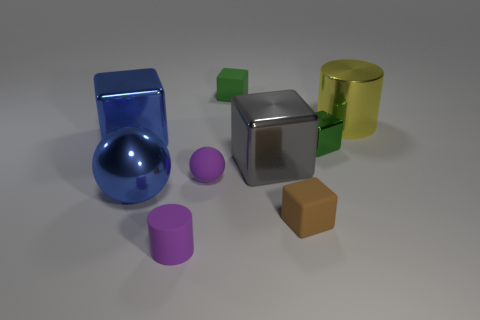How big is the block that is both to the right of the blue metallic sphere and to the left of the gray metallic thing?
Make the answer very short. Small. What material is the gray object that is the same shape as the small brown matte thing?
Give a very brief answer. Metal. How many purple matte balls are there?
Provide a succinct answer. 1. There is a purple rubber thing that is in front of the big metal ball; is its shape the same as the large yellow thing?
Keep it short and to the point. Yes. There is a green object that is the same size as the green matte block; what is its material?
Your response must be concise. Metal. Is there a purple sphere made of the same material as the brown thing?
Keep it short and to the point. Yes. There is a small green matte object; is it the same shape as the big blue thing left of the blue ball?
Give a very brief answer. Yes. What number of things are both in front of the gray object and on the left side of the brown block?
Your response must be concise. 3. Are the yellow cylinder and the block that is in front of the purple rubber sphere made of the same material?
Your response must be concise. No. Are there the same number of tiny purple cylinders behind the small brown object and yellow objects?
Give a very brief answer. No. 